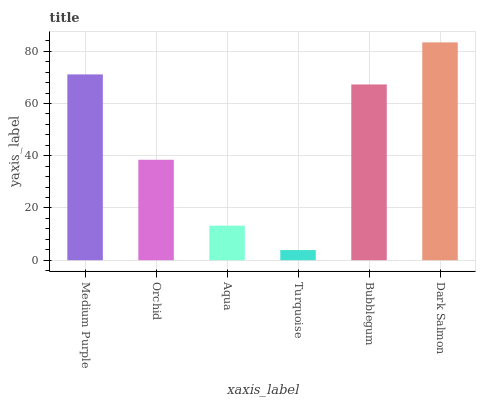Is Turquoise the minimum?
Answer yes or no. Yes. Is Dark Salmon the maximum?
Answer yes or no. Yes. Is Orchid the minimum?
Answer yes or no. No. Is Orchid the maximum?
Answer yes or no. No. Is Medium Purple greater than Orchid?
Answer yes or no. Yes. Is Orchid less than Medium Purple?
Answer yes or no. Yes. Is Orchid greater than Medium Purple?
Answer yes or no. No. Is Medium Purple less than Orchid?
Answer yes or no. No. Is Bubblegum the high median?
Answer yes or no. Yes. Is Orchid the low median?
Answer yes or no. Yes. Is Orchid the high median?
Answer yes or no. No. Is Bubblegum the low median?
Answer yes or no. No. 